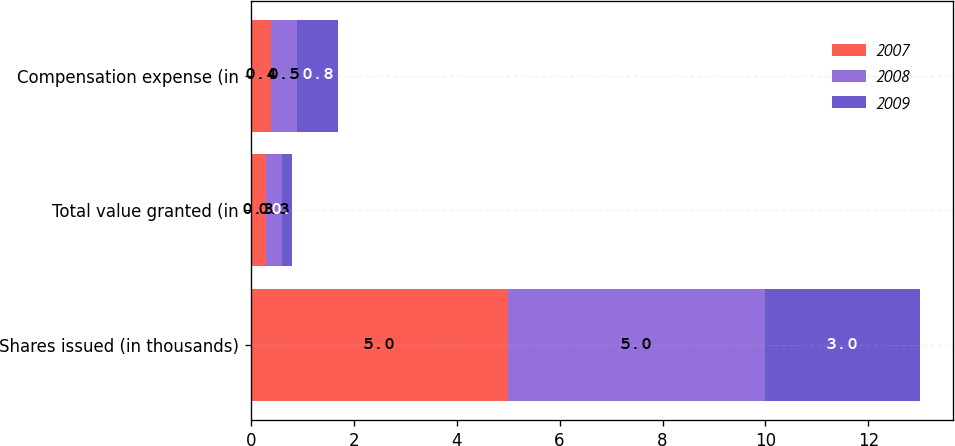Convert chart. <chart><loc_0><loc_0><loc_500><loc_500><stacked_bar_chart><ecel><fcel>Shares issued (in thousands)<fcel>Total value granted (in<fcel>Compensation expense (in<nl><fcel>2007<fcel>5<fcel>0.3<fcel>0.4<nl><fcel>2008<fcel>5<fcel>0.3<fcel>0.5<nl><fcel>2009<fcel>3<fcel>0.2<fcel>0.8<nl></chart> 